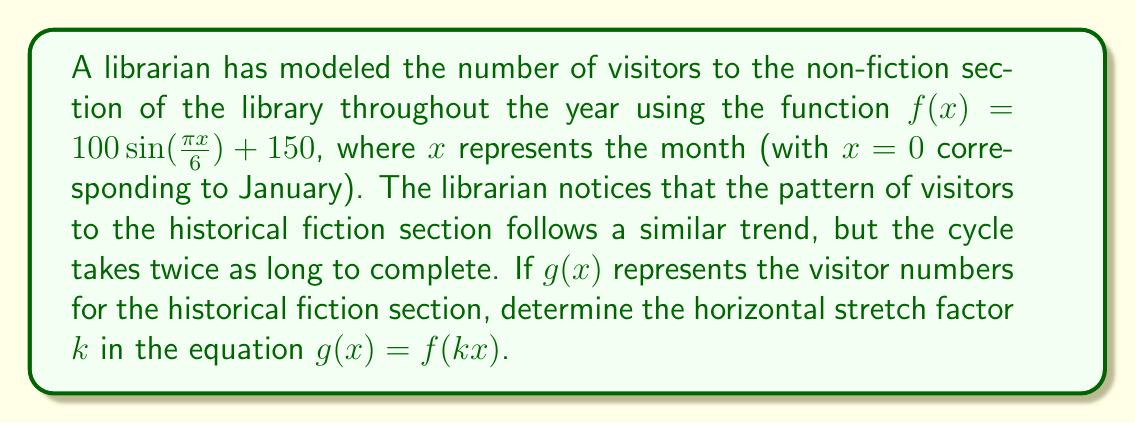Solve this math problem. To solve this problem, we need to understand the concept of horizontal stretching and how it affects the period of a trigonometric function.

1) The original function $f(x) = 100 \sin(\frac{\pi x}{6}) + 150$ has a period of 12 months. We can see this because:
   
   Period = $\frac{2\pi}{\left|\frac{\pi}{6}\right|} = 12$

2) The new function $g(x)$ has a cycle that takes twice as long to complete. This means its period is 24 months.

3) When we apply a horizontal stretch by a factor of $k$ to $f(x)$, we get $g(x) = f(kx)$:
   
   $g(x) = 100 \sin(\frac{\pi (kx)}{6}) + 150$

4) The period of this new function is:
   
   Period = $\frac{2\pi}{\left|\frac{\pi k}{6}\right|} = \frac{12}{|k|}$

5) We know this period should be 24 months, so we can set up the equation:

   $\frac{12}{|k|} = 24$

6) Solving for $k$:
   
   $|k| = \frac{12}{24} = \frac{1}{2}$

7) Since we're stretching the function horizontally (making the period longer), $k$ must be positive. Therefore:

   $k = \frac{1}{2}$
Answer: The horizontal stretch factor $k$ in the equation $g(x) = f(kx)$ is $\frac{1}{2}$. 